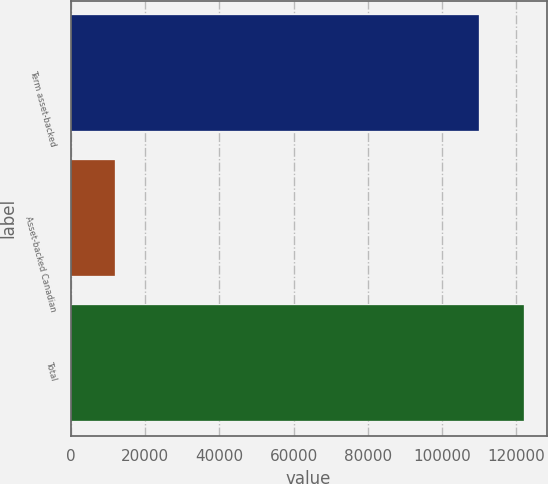Convert chart to OTSL. <chart><loc_0><loc_0><loc_500><loc_500><bar_chart><fcel>Term asset-backed<fcel>Asset-backed Canadian<fcel>Total<nl><fcel>110017<fcel>12035<fcel>122052<nl></chart> 